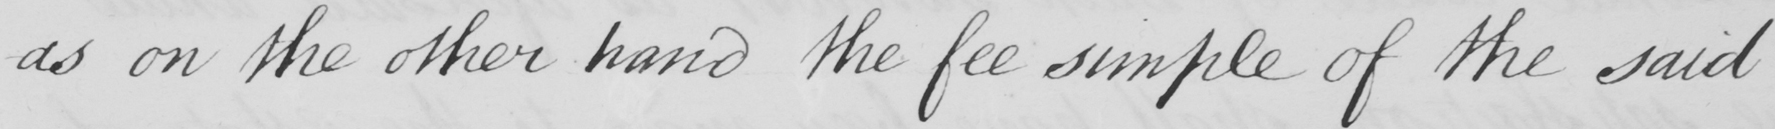Can you tell me what this handwritten text says? -as on the other hand the fee simple of the said 